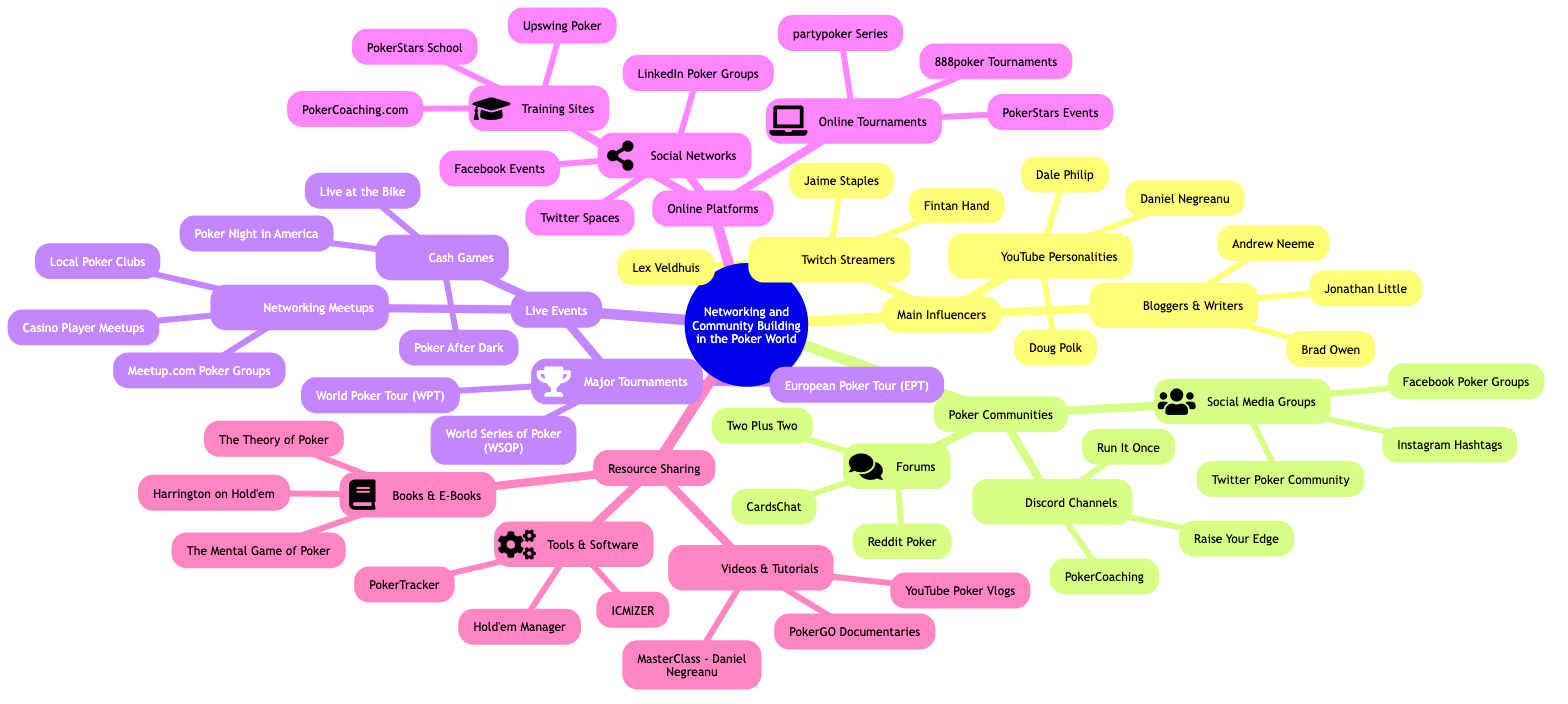What are the three categories of Main Influencers in the poker world? In the diagram, the Main Influencers are divided into three categories: YouTube Personalities, Twitch Streamers, and Bloggers & Writers.
Answer: YouTube Personalities, Twitch Streamers, Bloggers & Writers How many Discord Channels are listed in the Poker Communities section? The diagram shows three Discord Channels under the Poker Communities section: Run It Once, Raise Your Edge, and PokerCoaching.
Answer: 3 Which major tournament is included in the Live Events category? Looking at the Live Events section, one of the major tournaments listed is the World Series of Poker (WSOP).
Answer: World Series of Poker (WSOP) Name one Training Site from the Online Platforms section. From the Online Platforms section, one example of a Training Site is Upswing Poker.
Answer: Upswing Poker What type of resource is "The Theory of Poker"? In the Resource Sharing section, "The Theory of Poker" is categorized under Books & E-Books.
Answer: Books & E-Books Which social media platform is mentioned alongside Poker Communities? Within the Poker Communities section, Facebook Poker Groups are specifically noted as a part of social media.
Answer: Facebook Poker Groups What is the total number of major tournaments listed under Live Events? The diagram presents three Major Tournaments in the Live Events category: WSOP, EPT, and WPT, totaling three.
Answer: 3 Identify a YouTube personality associated with the Main Influencers. The diagram lists Dale Philip as one of the YouTube Personalities in the Main Influencers category.
Answer: Dale Philip Which section includes "MasterClass - Daniel Negreanu"? "MasterClass - Daniel Negreanu" is found in the Videos & Tutorials subsection of the Resource Sharing section.
Answer: Videos & Tutorials 